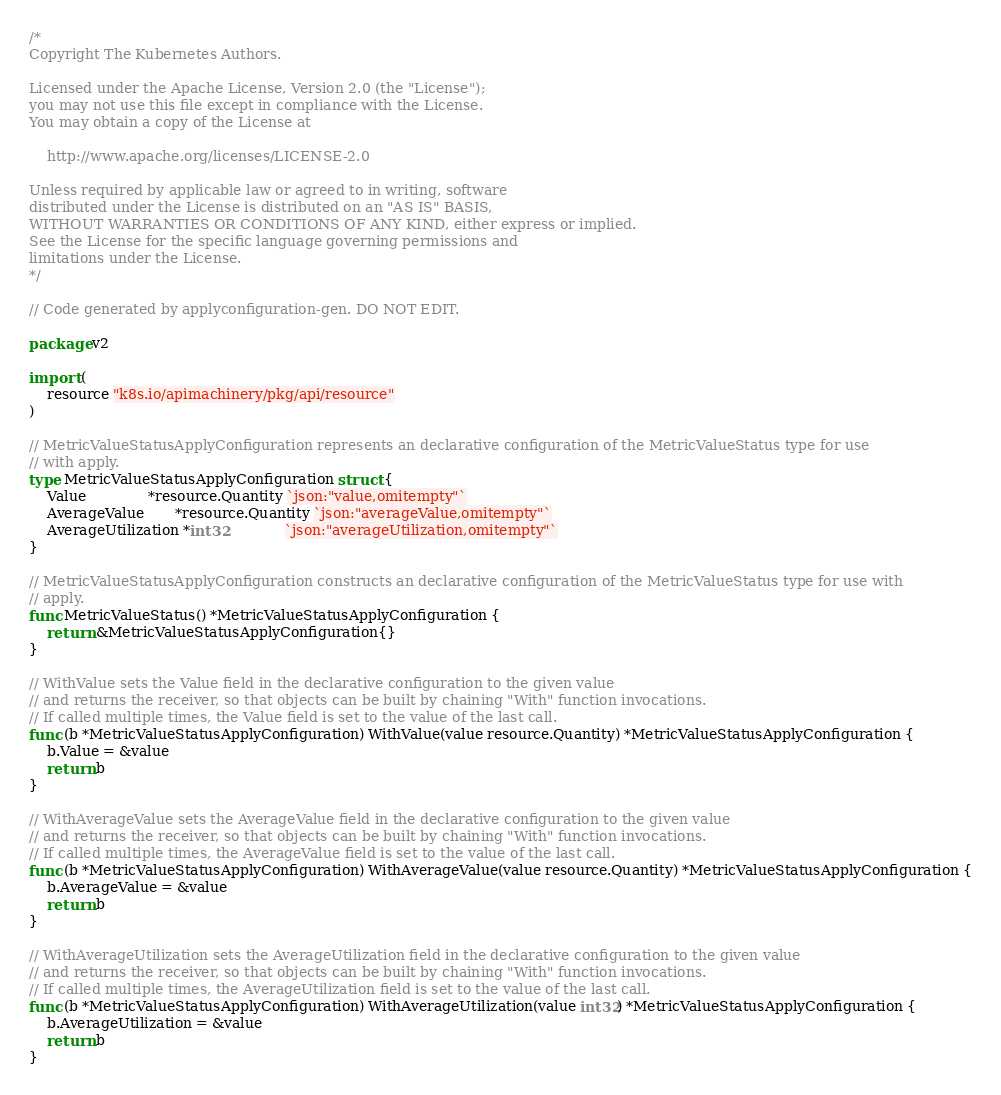<code> <loc_0><loc_0><loc_500><loc_500><_Go_>/*
Copyright The Kubernetes Authors.

Licensed under the Apache License, Version 2.0 (the "License");
you may not use this file except in compliance with the License.
You may obtain a copy of the License at

    http://www.apache.org/licenses/LICENSE-2.0

Unless required by applicable law or agreed to in writing, software
distributed under the License is distributed on an "AS IS" BASIS,
WITHOUT WARRANTIES OR CONDITIONS OF ANY KIND, either express or implied.
See the License for the specific language governing permissions and
limitations under the License.
*/

// Code generated by applyconfiguration-gen. DO NOT EDIT.

package v2

import (
	resource "k8s.io/apimachinery/pkg/api/resource"
)

// MetricValueStatusApplyConfiguration represents an declarative configuration of the MetricValueStatus type for use
// with apply.
type MetricValueStatusApplyConfiguration struct {
	Value              *resource.Quantity `json:"value,omitempty"`
	AverageValue       *resource.Quantity `json:"averageValue,omitempty"`
	AverageUtilization *int32             `json:"averageUtilization,omitempty"`
}

// MetricValueStatusApplyConfiguration constructs an declarative configuration of the MetricValueStatus type for use with
// apply.
func MetricValueStatus() *MetricValueStatusApplyConfiguration {
	return &MetricValueStatusApplyConfiguration{}
}

// WithValue sets the Value field in the declarative configuration to the given value
// and returns the receiver, so that objects can be built by chaining "With" function invocations.
// If called multiple times, the Value field is set to the value of the last call.
func (b *MetricValueStatusApplyConfiguration) WithValue(value resource.Quantity) *MetricValueStatusApplyConfiguration {
	b.Value = &value
	return b
}

// WithAverageValue sets the AverageValue field in the declarative configuration to the given value
// and returns the receiver, so that objects can be built by chaining "With" function invocations.
// If called multiple times, the AverageValue field is set to the value of the last call.
func (b *MetricValueStatusApplyConfiguration) WithAverageValue(value resource.Quantity) *MetricValueStatusApplyConfiguration {
	b.AverageValue = &value
	return b
}

// WithAverageUtilization sets the AverageUtilization field in the declarative configuration to the given value
// and returns the receiver, so that objects can be built by chaining "With" function invocations.
// If called multiple times, the AverageUtilization field is set to the value of the last call.
func (b *MetricValueStatusApplyConfiguration) WithAverageUtilization(value int32) *MetricValueStatusApplyConfiguration {
	b.AverageUtilization = &value
	return b
}
</code> 